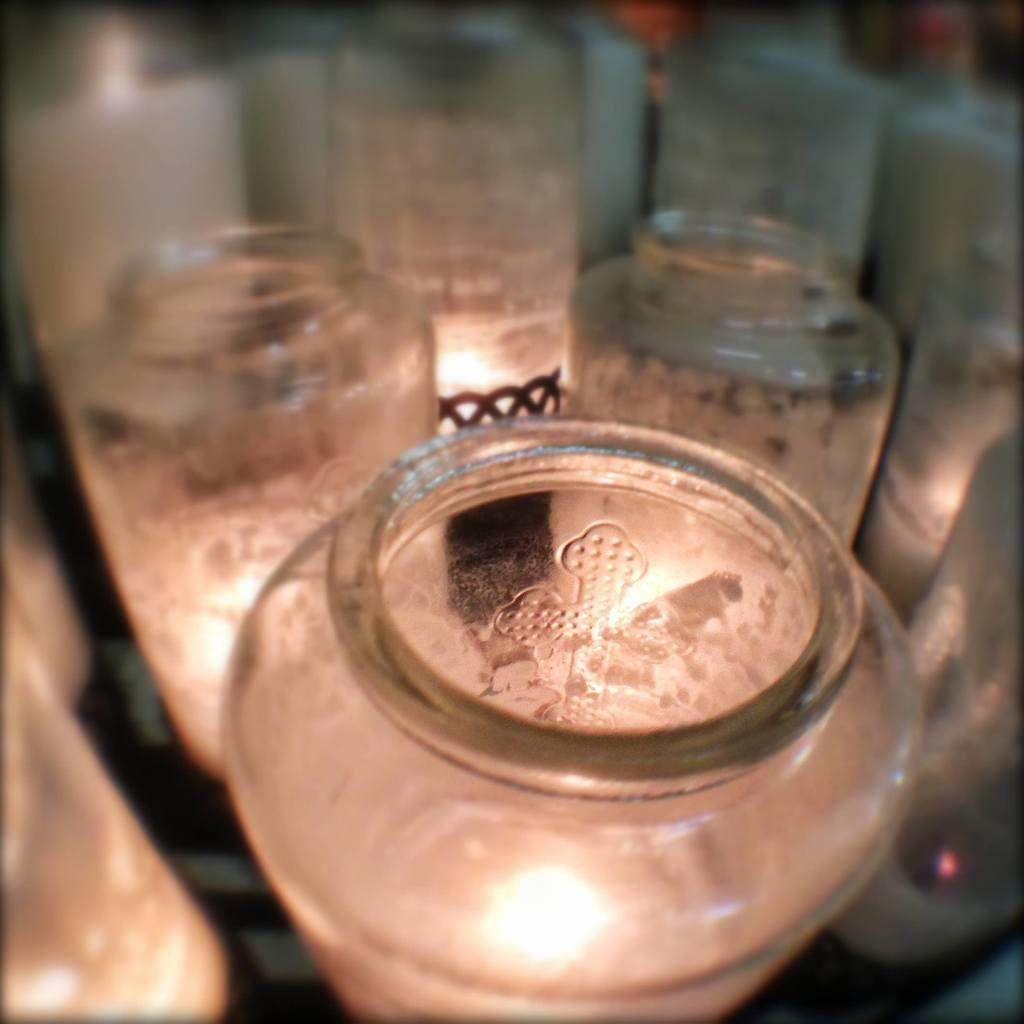In one or two sentences, can you explain what this image depicts? This image consists of a glass bottles which are empty and which are kept on the floor. It looks as if the image is taken inside a room. 